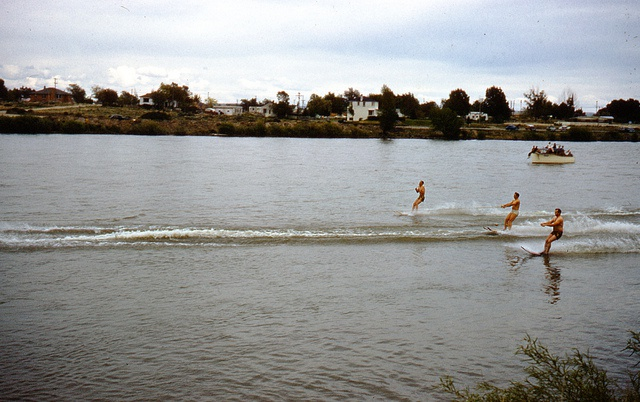Describe the objects in this image and their specific colors. I can see boat in lightgray, darkgray, black, tan, and maroon tones, people in lightgray, maroon, black, brown, and gray tones, people in lightgray, brown, maroon, darkgray, and tan tones, surfboard in lightgray, darkgray, and gray tones, and people in lightgray, brown, maroon, lightblue, and darkgray tones in this image. 